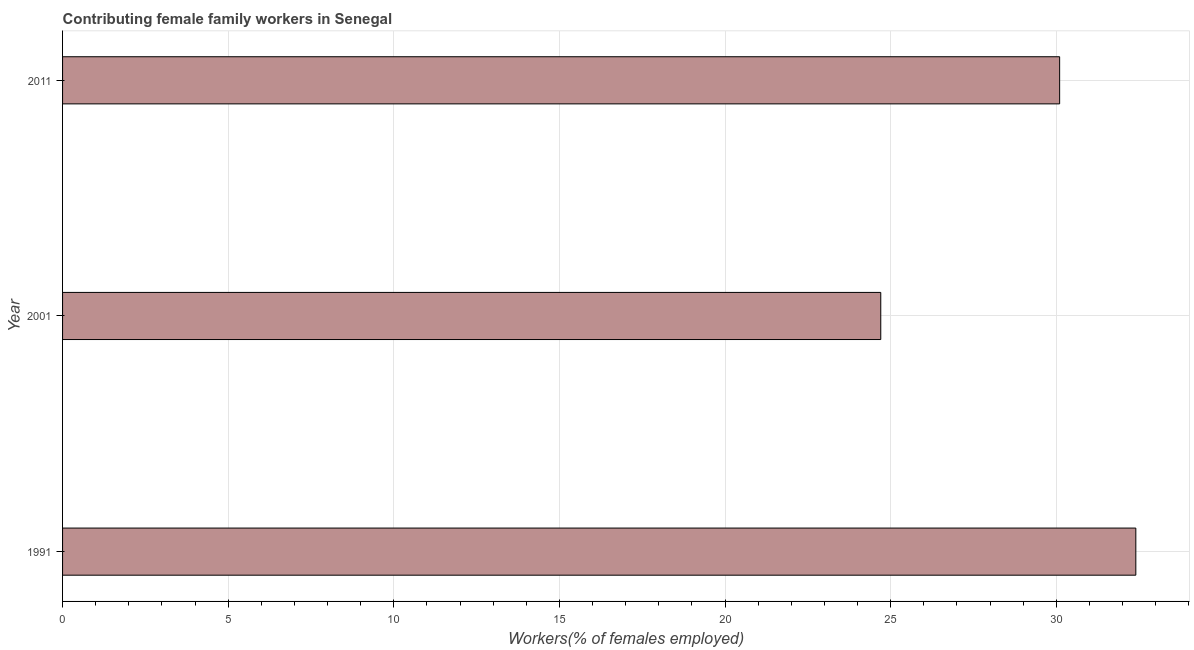Does the graph contain any zero values?
Make the answer very short. No. Does the graph contain grids?
Make the answer very short. Yes. What is the title of the graph?
Provide a short and direct response. Contributing female family workers in Senegal. What is the label or title of the X-axis?
Provide a short and direct response. Workers(% of females employed). What is the label or title of the Y-axis?
Keep it short and to the point. Year. What is the contributing female family workers in 1991?
Provide a succinct answer. 32.4. Across all years, what is the maximum contributing female family workers?
Your answer should be very brief. 32.4. Across all years, what is the minimum contributing female family workers?
Provide a succinct answer. 24.7. In which year was the contributing female family workers maximum?
Give a very brief answer. 1991. In which year was the contributing female family workers minimum?
Ensure brevity in your answer.  2001. What is the sum of the contributing female family workers?
Offer a terse response. 87.2. What is the average contributing female family workers per year?
Offer a terse response. 29.07. What is the median contributing female family workers?
Provide a short and direct response. 30.1. In how many years, is the contributing female family workers greater than 18 %?
Provide a short and direct response. 3. Do a majority of the years between 1991 and 2001 (inclusive) have contributing female family workers greater than 29 %?
Provide a short and direct response. No. What is the ratio of the contributing female family workers in 2001 to that in 2011?
Your answer should be very brief. 0.82. Is the difference between the contributing female family workers in 1991 and 2011 greater than the difference between any two years?
Provide a short and direct response. No. Is the sum of the contributing female family workers in 1991 and 2001 greater than the maximum contributing female family workers across all years?
Provide a succinct answer. Yes. What is the Workers(% of females employed) in 1991?
Provide a short and direct response. 32.4. What is the Workers(% of females employed) of 2001?
Give a very brief answer. 24.7. What is the Workers(% of females employed) of 2011?
Offer a terse response. 30.1. What is the difference between the Workers(% of females employed) in 1991 and 2011?
Keep it short and to the point. 2.3. What is the ratio of the Workers(% of females employed) in 1991 to that in 2001?
Provide a succinct answer. 1.31. What is the ratio of the Workers(% of females employed) in 1991 to that in 2011?
Your response must be concise. 1.08. What is the ratio of the Workers(% of females employed) in 2001 to that in 2011?
Your answer should be very brief. 0.82. 